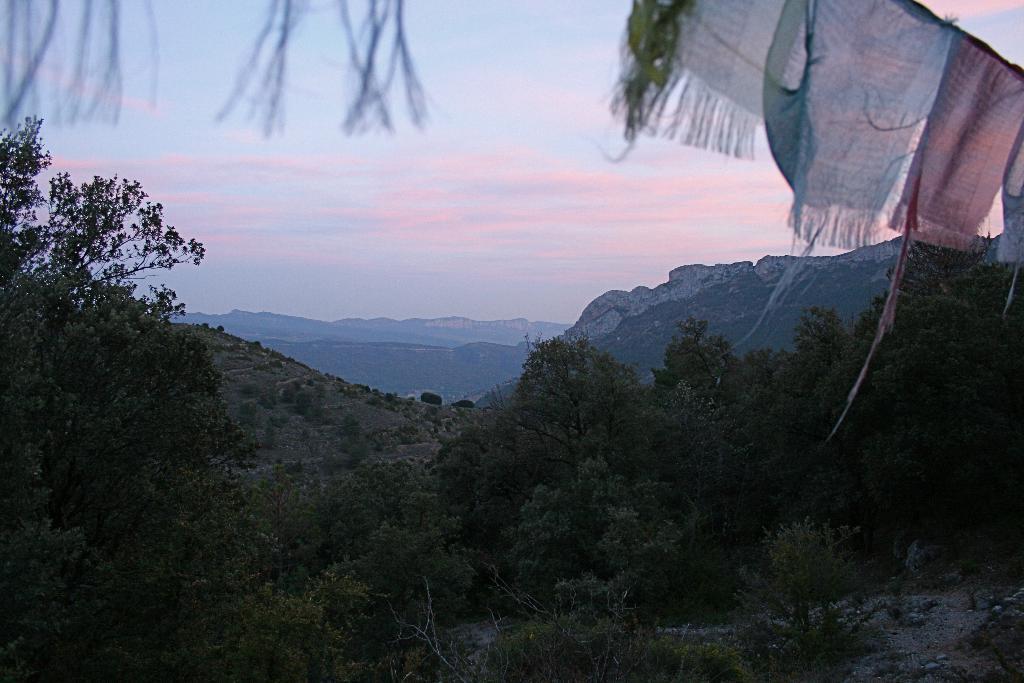How would you summarize this image in a sentence or two? In this image I can see trees and clothes are hanging at the top. There are mountains at the back and sky at the top. 